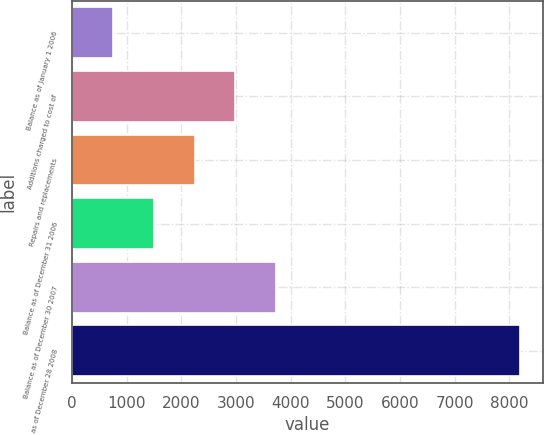<chart> <loc_0><loc_0><loc_500><loc_500><bar_chart><fcel>Balance as of January 1 2006<fcel>Additions charged to cost of<fcel>Repairs and replacements<fcel>Balance as of December 31 2006<fcel>Balance as of December 30 2007<fcel>Balance as of December 28 2008<nl><fcel>751<fcel>2986.6<fcel>2241.4<fcel>1496.2<fcel>3731.8<fcel>8203<nl></chart> 